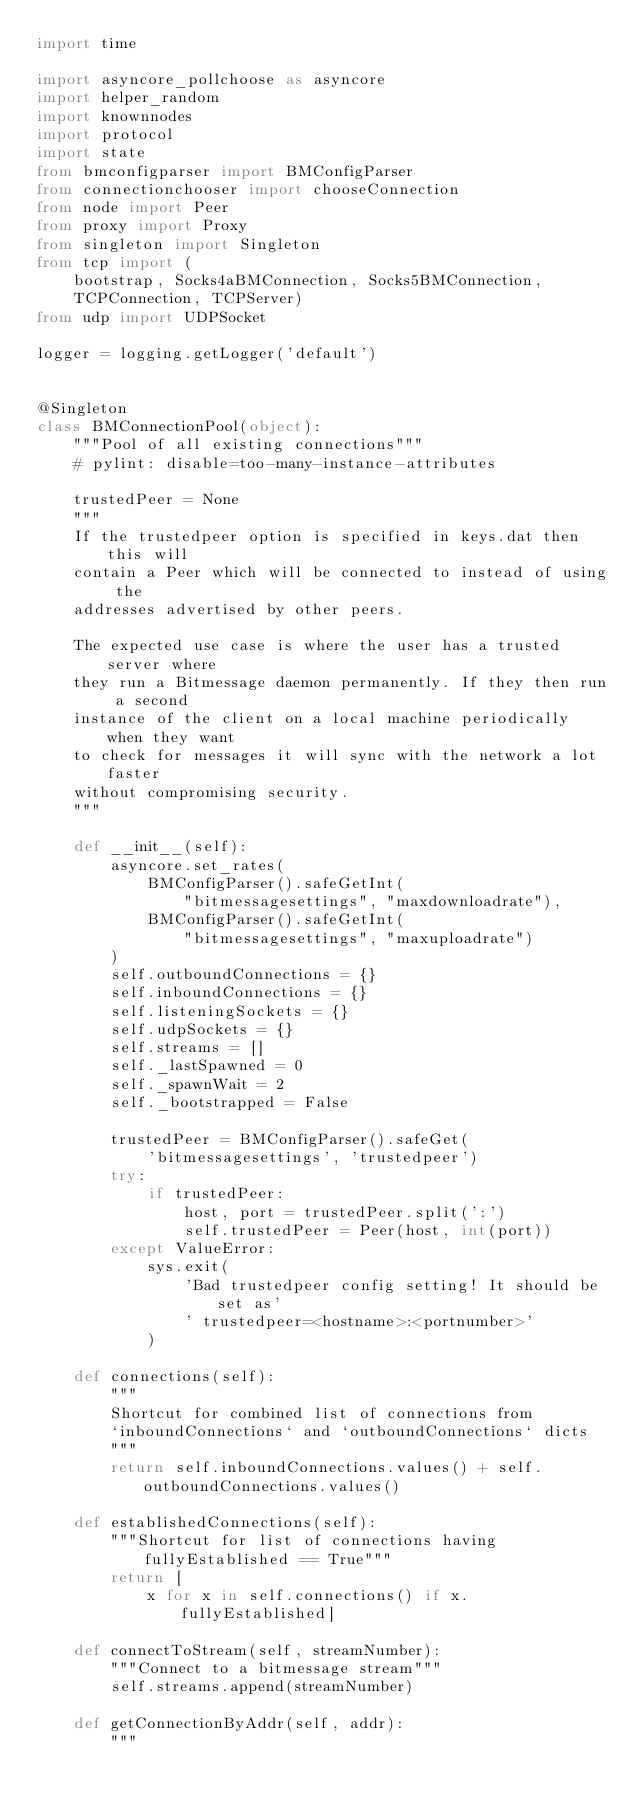Convert code to text. <code><loc_0><loc_0><loc_500><loc_500><_Python_>import time

import asyncore_pollchoose as asyncore
import helper_random
import knownnodes
import protocol
import state
from bmconfigparser import BMConfigParser
from connectionchooser import chooseConnection
from node import Peer
from proxy import Proxy
from singleton import Singleton
from tcp import (
    bootstrap, Socks4aBMConnection, Socks5BMConnection,
    TCPConnection, TCPServer)
from udp import UDPSocket

logger = logging.getLogger('default')


@Singleton
class BMConnectionPool(object):
    """Pool of all existing connections"""
    # pylint: disable=too-many-instance-attributes

    trustedPeer = None
    """
    If the trustedpeer option is specified in keys.dat then this will
    contain a Peer which will be connected to instead of using the
    addresses advertised by other peers.

    The expected use case is where the user has a trusted server where
    they run a Bitmessage daemon permanently. If they then run a second
    instance of the client on a local machine periodically when they want
    to check for messages it will sync with the network a lot faster
    without compromising security.
    """

    def __init__(self):
        asyncore.set_rates(
            BMConfigParser().safeGetInt(
                "bitmessagesettings", "maxdownloadrate"),
            BMConfigParser().safeGetInt(
                "bitmessagesettings", "maxuploadrate")
        )
        self.outboundConnections = {}
        self.inboundConnections = {}
        self.listeningSockets = {}
        self.udpSockets = {}
        self.streams = []
        self._lastSpawned = 0
        self._spawnWait = 2
        self._bootstrapped = False

        trustedPeer = BMConfigParser().safeGet(
            'bitmessagesettings', 'trustedpeer')
        try:
            if trustedPeer:
                host, port = trustedPeer.split(':')
                self.trustedPeer = Peer(host, int(port))
        except ValueError:
            sys.exit(
                'Bad trustedpeer config setting! It should be set as'
                ' trustedpeer=<hostname>:<portnumber>'
            )

    def connections(self):
        """
        Shortcut for combined list of connections from
        `inboundConnections` and `outboundConnections` dicts
        """
        return self.inboundConnections.values() + self.outboundConnections.values()

    def establishedConnections(self):
        """Shortcut for list of connections having fullyEstablished == True"""
        return [
            x for x in self.connections() if x.fullyEstablished]

    def connectToStream(self, streamNumber):
        """Connect to a bitmessage stream"""
        self.streams.append(streamNumber)

    def getConnectionByAddr(self, addr):
        """</code> 